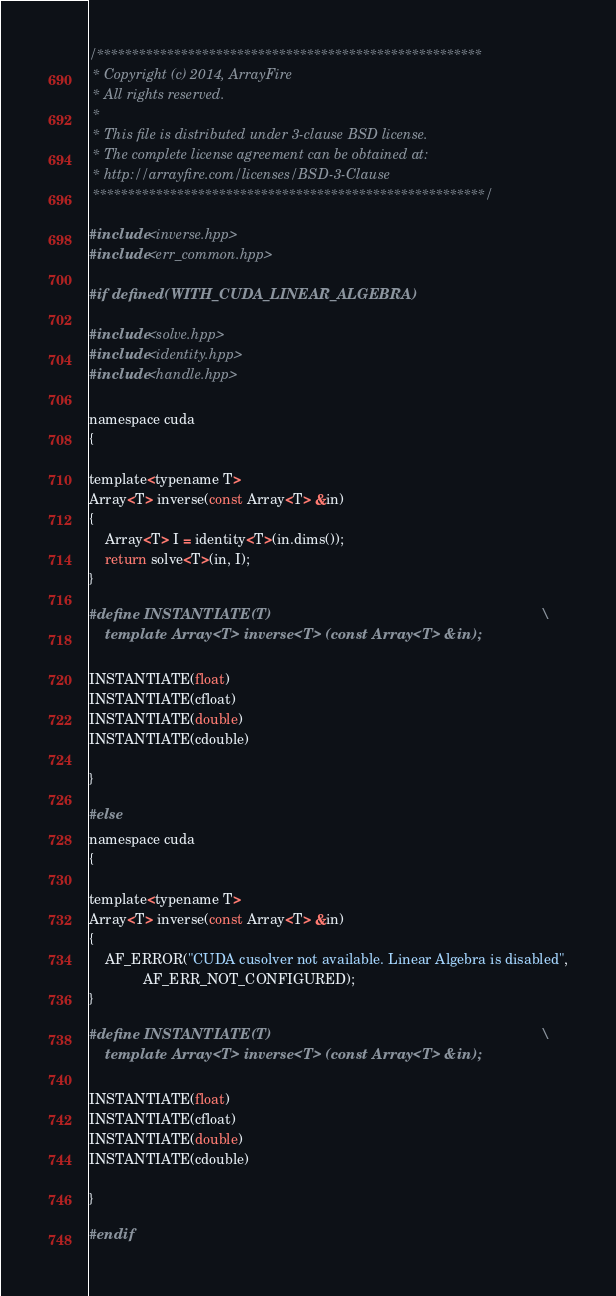Convert code to text. <code><loc_0><loc_0><loc_500><loc_500><_Cuda_>/*******************************************************
 * Copyright (c) 2014, ArrayFire
 * All rights reserved.
 *
 * This file is distributed under 3-clause BSD license.
 * The complete license agreement can be obtained at:
 * http://arrayfire.com/licenses/BSD-3-Clause
 ********************************************************/

#include <inverse.hpp>
#include <err_common.hpp>

#if defined(WITH_CUDA_LINEAR_ALGEBRA)

#include <solve.hpp>
#include <identity.hpp>
#include <handle.hpp>

namespace cuda
{

template<typename T>
Array<T> inverse(const Array<T> &in)
{
    Array<T> I = identity<T>(in.dims());
    return solve<T>(in, I);
}

#define INSTANTIATE(T)                                                                   \
    template Array<T> inverse<T> (const Array<T> &in);

INSTANTIATE(float)
INSTANTIATE(cfloat)
INSTANTIATE(double)
INSTANTIATE(cdouble)

}

#else
namespace cuda
{

template<typename T>
Array<T> inverse(const Array<T> &in)
{
    AF_ERROR("CUDA cusolver not available. Linear Algebra is disabled",
              AF_ERR_NOT_CONFIGURED);
}

#define INSTANTIATE(T)                                                                   \
    template Array<T> inverse<T> (const Array<T> &in);

INSTANTIATE(float)
INSTANTIATE(cfloat)
INSTANTIATE(double)
INSTANTIATE(cdouble)

}

#endif
</code> 